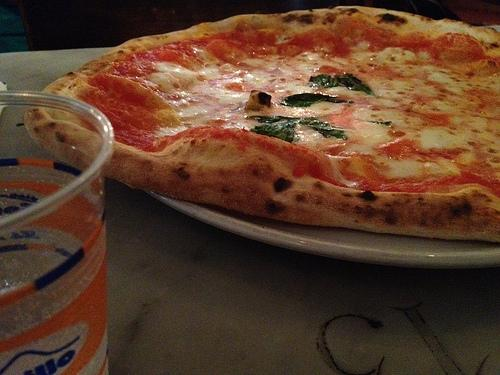Highlight the primary dish in the image along with the drink accompanying it. A small cheese pizza with basil leaves is on the table, accompanied by a cup of clear, sparkling liquid in an orange and blue cup. Using casual language, describe the main parts of the image regarding food. There's this pizza for one, with cheese, red sauce, and basil on it, all on a plate. And next to it is a cup of water or maybe soda. Provide a brief description of the scene focusing on the main dish and its setting. A cheese and basil pizza sits on a white porcelain plate atop a fancy printed cloth tablecloth, accompanied by a cup of water. Visually walk through the image and mention the main focus and its surroundings. A pizza, laid on a round plate, catches the eye with its toppings of red sauce, cheese, basil, and a thin crust, as a cup of water sits nearby. Write about the main meal in the image along with any notable characteristics. A cheese and basil pizza, with toasted white cheese and thin crispy crust, is served on a silver dish with a few burned spots. Portray the main components and features of the image in a simplified manner. A small cheese pizza, with basil and burnt crust, is placed on a round plate, next to a blue, orange, and clear cup holding water or soda. Elaborate on the food in the image without explicitly mentioning it is a pizza. A circular dish topped with red tomato sauce, white melted cheese, and green basil leaves, sits on a marble table surrounded by burnt crust. Mention the primary food item in the image and any toppings on it. A small cheese pizza is present, topped with red sauce, melted mozzarella cheese, and green basil leaves. Narrate the image in a poetic manner, focusing on the main elements. Amidst a late night dinner, a delightful cheese and basil pizza rests elegantly upon a white round plate, as a bubbly clear drink shares the stage. Describe the dish and drink in the image as if explaining it to a child. There's a yummy cheese and basil pizza on a plate, and next to it is a cup filled with bubbles and water, both on a pretty tablecloth. 